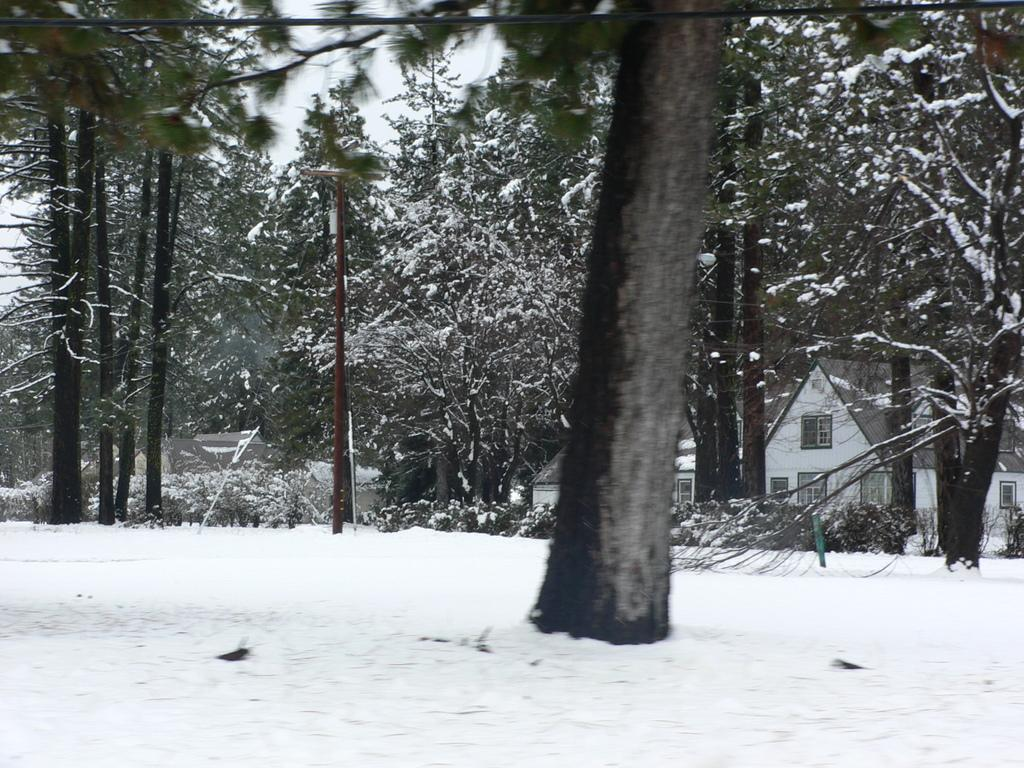What is the predominant weather condition in the image? There is snow in the image, indicating a cold and wintry condition. What type of natural elements can be seen in the image? There are trees in the image. What structures are visible in the background of the image? There are houses, an electric pole, and a metal pole in the background of the image. What type of appliance is being used by the judge in the image? There is no judge or appliance present in the image. How many cakes are being served at the party in the image? There is no party or cakes present in the image. 